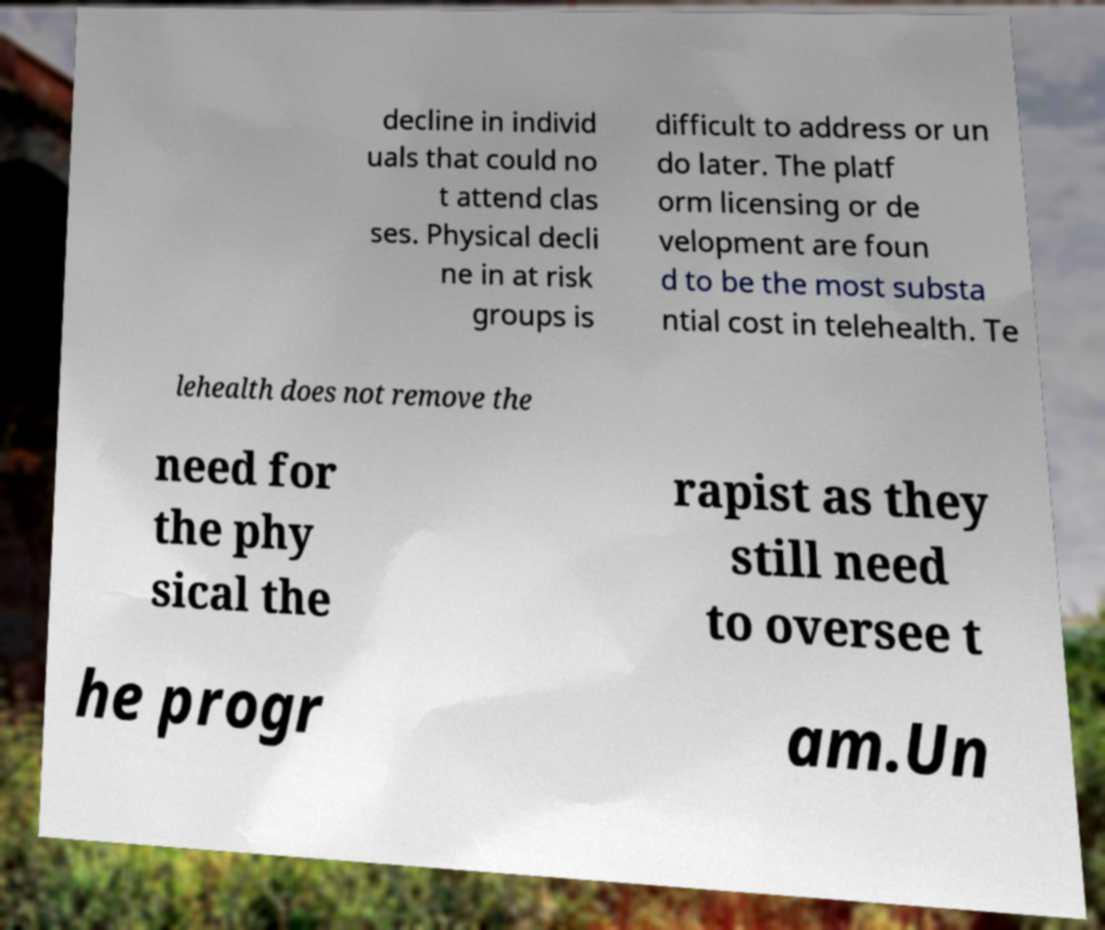Can you read and provide the text displayed in the image?This photo seems to have some interesting text. Can you extract and type it out for me? decline in individ uals that could no t attend clas ses. Physical decli ne in at risk groups is difficult to address or un do later. The platf orm licensing or de velopment are foun d to be the most substa ntial cost in telehealth. Te lehealth does not remove the need for the phy sical the rapist as they still need to oversee t he progr am.Un 